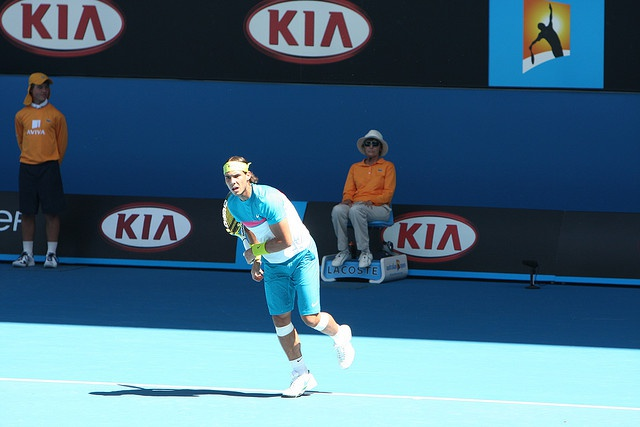Describe the objects in this image and their specific colors. I can see people in black, white, lightblue, gray, and teal tones, people in black, brown, and maroon tones, people in black, brown, gray, and maroon tones, tennis racket in black, white, olive, and gray tones, and chair in black, navy, and blue tones in this image. 